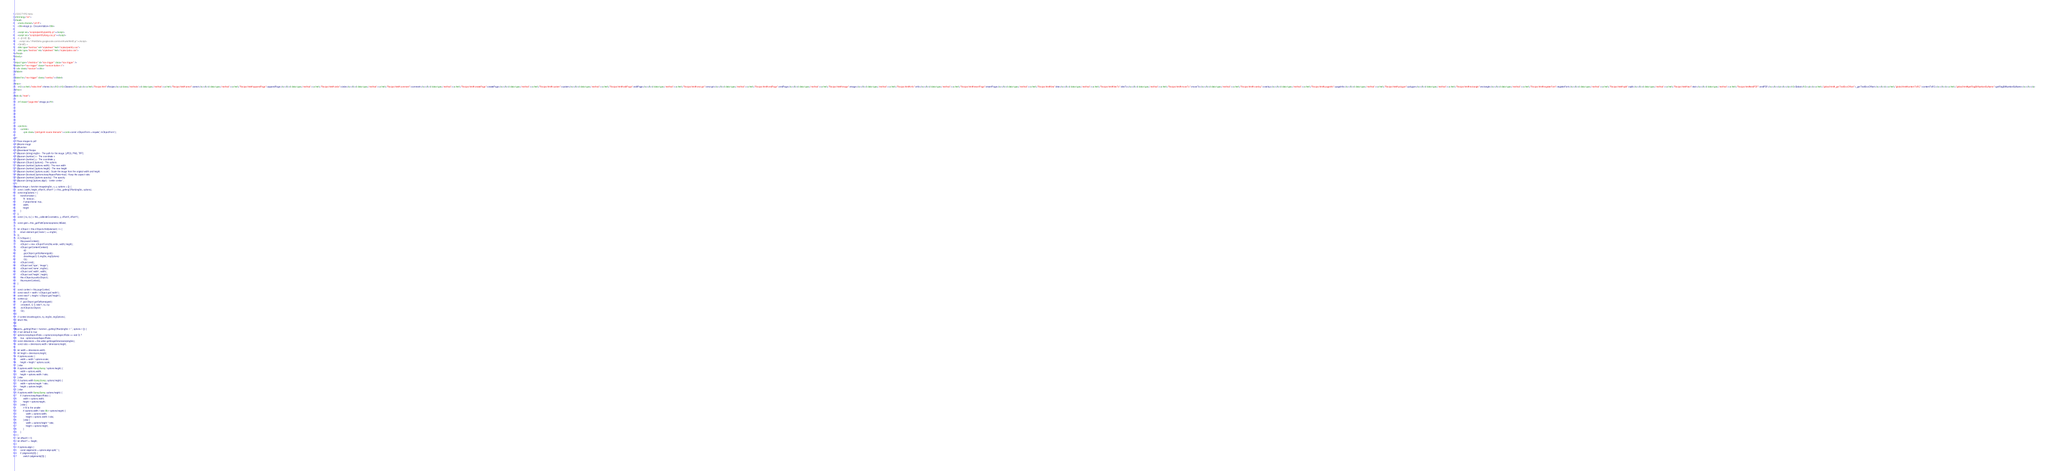Convert code to text. <code><loc_0><loc_0><loc_500><loc_500><_HTML_><!DOCTYPE html>
<html lang="en">
<head>
    <meta charset="utf-8">
    <title>image.js - Documentation</title>

    <script src="scripts/prettify/prettify.js"></script>
    <script src="scripts/prettify/lang-css.js"></script>
    <!--[if lt IE 9]>
      <script src="//html5shiv.googlecode.com/svn/trunk/html5.js"></script>
    <![endif]-->
    <link type="text/css" rel="stylesheet" href="styles/prettify.css">
    <link type="text/css" rel="stylesheet" href="styles/jsdoc.css">
</head>
<body>

<input type="checkbox" id="nav-trigger" class="nav-trigger" />
<label for="nav-trigger" class="navicon-button x">
  <div class="navicon"></div>
</label>

<label for="nav-trigger" class="overlay"></label>

<nav>
    <h2><a href="index.html">Home</a></h2><h3>Classes</h3><ul><li><a href="Recipe.html">Recipe</a><ul class='methods'><li data-type='method'><a href="Recipe.html#.annot">annot</a></li><li data-type='method'><a href="Recipe.html#.appendPage">appendPage</a></li><li data-type='method'><a href="Recipe.html#.circle">circle</a></li><li data-type='method'><a href="Recipe.html#.comment">comment</a></li><li data-type='method'><a href="Recipe.html#.createPage">createPage</a></li><li data-type='method'><a href="Recipe.html#.custom">custom</a></li><li data-type='method'><a href="Recipe.html#.editPage">editPage</a></li><li data-type='method'><a href="Recipe.html#.encrypt">encrypt</a></li><li data-type='method'><a href="Recipe.html#.endPage">endPage</a></li><li data-type='method'><a href="Recipe.html#.image">image</a></li><li data-type='method'><a href="Recipe.html#.info">info</a></li><li data-type='method'><a href="Recipe.html#.insertPage">insertPage</a></li><li data-type='method'><a href="Recipe.html#.line">line</a></li><li data-type='method'><a href="Recipe.html#.lineTo">lineTo</a></li><li data-type='method'><a href="Recipe.html#.moveTo">moveTo</a></li><li data-type='method'><a href="Recipe.html#.overlay">overlay</a></li><li data-type='method'><a href="Recipe.html#.pageInfo">pageInfo</a></li><li data-type='method'><a href="Recipe.html#.polygon">polygon</a></li><li data-type='method'><a href="Recipe.html#.rectangle">rectangle</a></li><li data-type='method'><a href="Recipe.html#.registerFont">registerFont</a></li><li data-type='method'><a href="Recipe.html#.split">split</a></li><li data-type='method'><a href="Recipe.html#.text">text</a></li><li data-type='method'><a href="Recipe.html#endPDF">endPDF</a></li></ul></li></ul><h3>Global</h3><ul><li><a href="global.html#_getTextBoxOffset">_getTextBoxOffset</a></li><li><a href="global.html#contentToRC">contentToRC</a></li><li><a href="global.html#getFlagBitNumberByName">getFlagBitNumberByName</a></li></ul>
</nav>

<div id="main">
    
    <h1 class="page-title">image.js</h1>
    

    



    
    <section>
        <article>
            <pre class="prettyprint source linenums"><code>const xObjectForm = require('./xObjectForm');

/**
 * Place images to pdf
 * @name image
 * @function
 * @memberof Recipe
 * @param {string} imgSrc - The path for the image. [JPEG, PNG, TIFF]
 * @param {number} x - The coordinate x
 * @param {number} y - The coordinate y
 * @param {Object} [options] - The options
 * @param {number} [options.width] - The new width
 * @param {number} [options.height] - The new height
 * @param {number} [options.scale] - Scale the image from the original width and height.
 * @param {boolean} [options.keepAspectRatio=true] - Keep the aspect ratio.
 * @param {number} [options.opacity] - The opacity.
 * @param {string} [options.align] - 'center center'...
 */
exports.image = function image(imgSrc, x, y, options = {}) {
    const { width, height, offsetX, offsetY } = this._getImgOffset(imgSrc, options);
    const imgOptions = {
        transformation: {
            fit: 'always',
            // proportional: true,
            width,
            height
        }
    };
    const { nx, ny } = this._calibrateCoorinate(x, y, offsetX, offsetY);

    const gsId = this._getPathOptions(options).fillGsId;

    let xObject = this.xObjects.find((element) => {
        return element.get('name') == imgSrc;
    });
    if (!xObject) {
        this.pauseContext();
        xObject = new xObjectForm(this.writer, width, height);
        xObject.getContentContext()
            .q()
            .gs(xObject.getGsName(gsId))
            .drawImage(0, 0, imgSrc, imgOptions)
            .Q();
        xObject.end();
        xObject.set('type', 'image');
        xObject.set('name', imgSrc);
        xObject.set('width', width);
        xObject.set('height', height);
        this.xObjects.push(xObject);
        this.resumeContext();
    }

    const context = this.pageContext;
    const ratioX = width / xObject.get('width');
    const ratioY = height / xObject.get('height');
    context.q()
        // .gs(xObject.getGsName(gsId))
        .cm(ratioX, 0, 0, ratioY, nx, ny)
        .doXObject(xObject)
        .Q();

    // context.drawImage(nx, ny, imgSrc, imgOptions);
    return this;
}

exports._getImgOffset = function _getImgOffset(imgSrc = '', options = {}) {
    // set default to true
    options.keepAspectRatio = (options.keepAspectRatio == void 0) ?
        true : options.keepAspectRatio;
    const dimensions = this.writer.getImageDimensions(imgSrc);
    const ratio = dimensions.width / dimensions.height;

    let width = dimensions.width;
    let height = dimensions.height;
    if (options.scale) {
        width = width * options.scale;
        height = height * options.scale;
    } else
    if (options.width &amp;&amp; !options.height) {
        width = options.width;
        height = options.width / ratio;
    } else
    if (!options.width &amp;&amp; options.height) {
        width = options.height * ratio;
        height = options.height;
    } else
    if (options.width &amp;&amp; options.height) {
        if (!options.keepAspectRatio) {
            width = options.width;
            height = options.height;
        } else {
            // fit to the smaller
            if (options.width / ratio &lt;= options.height) {
                width = options.width;
                height = options.width / ratio;
            } else {
                width = options.height * ratio;
                height = options.height;
            }
        }
    }
    let offsetX = 0;
    let offsetY = -height;

    if (options.align) {
        const alignments = options.align.split(' ');
        if (alignments[0]) {
            switch (alignments[0]) {</code> 